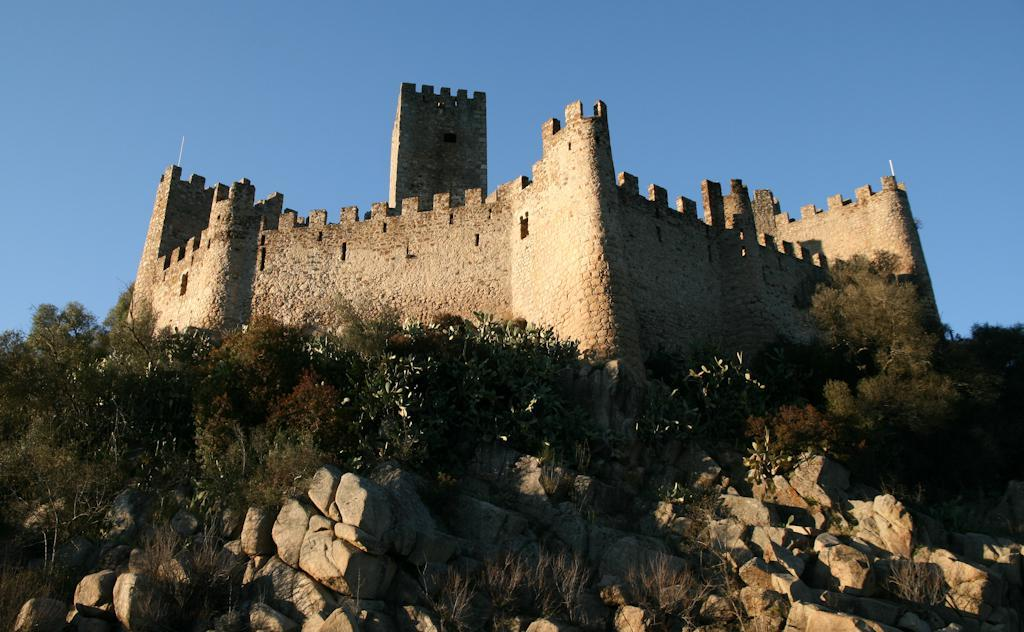What type of natural elements can be seen in the image? There are rocks and trees in the image. What type of structure is visible in the background of the image? There is a building in the background of the image. What part of the natural environment is visible in the image? The sky is visible in the background of the image. How does the sink help with the rocks in the image? There is no sink present in the image, so it cannot help with the rocks. 